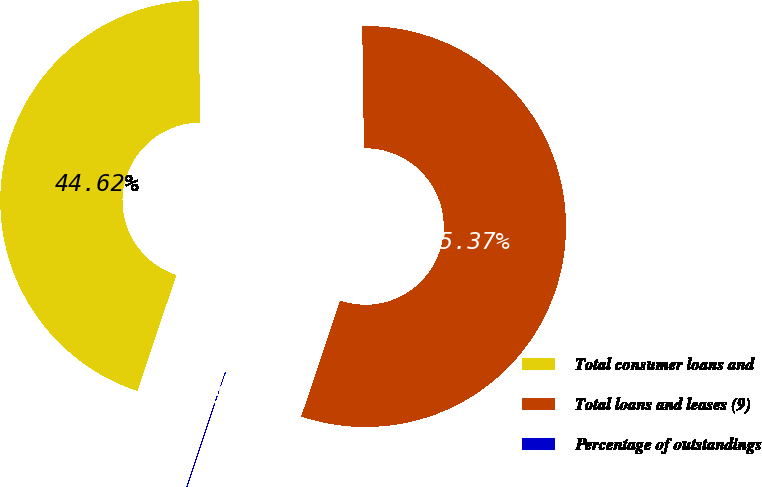Convert chart to OTSL. <chart><loc_0><loc_0><loc_500><loc_500><pie_chart><fcel>Total consumer loans and<fcel>Total loans and leases (9)<fcel>Percentage of outstandings<nl><fcel>44.62%<fcel>55.37%<fcel>0.01%<nl></chart> 